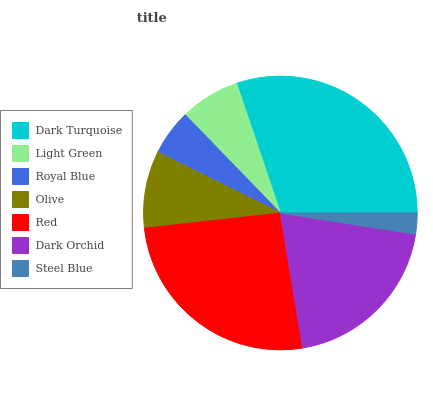Is Steel Blue the minimum?
Answer yes or no. Yes. Is Dark Turquoise the maximum?
Answer yes or no. Yes. Is Light Green the minimum?
Answer yes or no. No. Is Light Green the maximum?
Answer yes or no. No. Is Dark Turquoise greater than Light Green?
Answer yes or no. Yes. Is Light Green less than Dark Turquoise?
Answer yes or no. Yes. Is Light Green greater than Dark Turquoise?
Answer yes or no. No. Is Dark Turquoise less than Light Green?
Answer yes or no. No. Is Olive the high median?
Answer yes or no. Yes. Is Olive the low median?
Answer yes or no. Yes. Is Steel Blue the high median?
Answer yes or no. No. Is Light Green the low median?
Answer yes or no. No. 